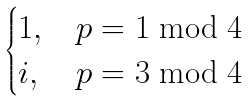<formula> <loc_0><loc_0><loc_500><loc_500>\begin{cases} 1 , & p = 1 \bmod 4 \\ i , & p = 3 \bmod 4 \end{cases}</formula> 